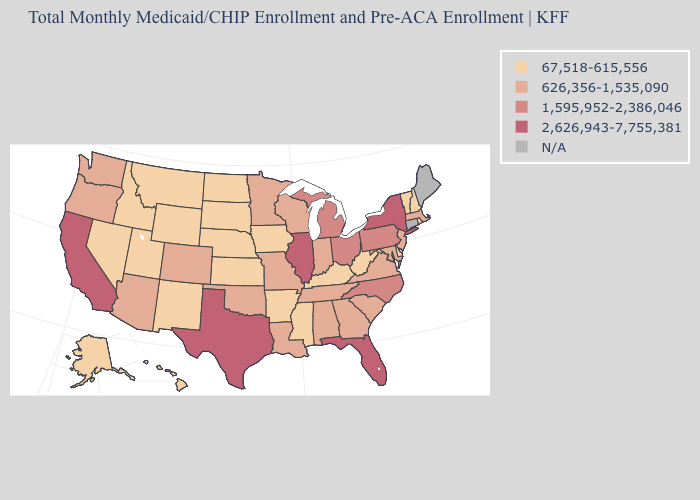Does the map have missing data?
Keep it brief. Yes. Among the states that border Virginia , does Kentucky have the highest value?
Short answer required. No. What is the value of Michigan?
Give a very brief answer. 1,595,952-2,386,046. What is the lowest value in the USA?
Quick response, please. 67,518-615,556. What is the value of Alabama?
Give a very brief answer. 626,356-1,535,090. Does the map have missing data?
Answer briefly. Yes. Which states have the lowest value in the USA?
Concise answer only. Alaska, Arkansas, Delaware, Hawaii, Idaho, Iowa, Kansas, Kentucky, Mississippi, Montana, Nebraska, Nevada, New Hampshire, New Mexico, North Dakota, Rhode Island, South Dakota, Utah, Vermont, West Virginia, Wyoming. What is the value of North Carolina?
Keep it brief. 1,595,952-2,386,046. What is the value of Minnesota?
Quick response, please. 626,356-1,535,090. Does Idaho have the highest value in the West?
Short answer required. No. What is the value of Minnesota?
Answer briefly. 626,356-1,535,090. Among the states that border Massachusetts , which have the lowest value?
Keep it brief. New Hampshire, Rhode Island, Vermont. What is the value of Ohio?
Write a very short answer. 1,595,952-2,386,046. 